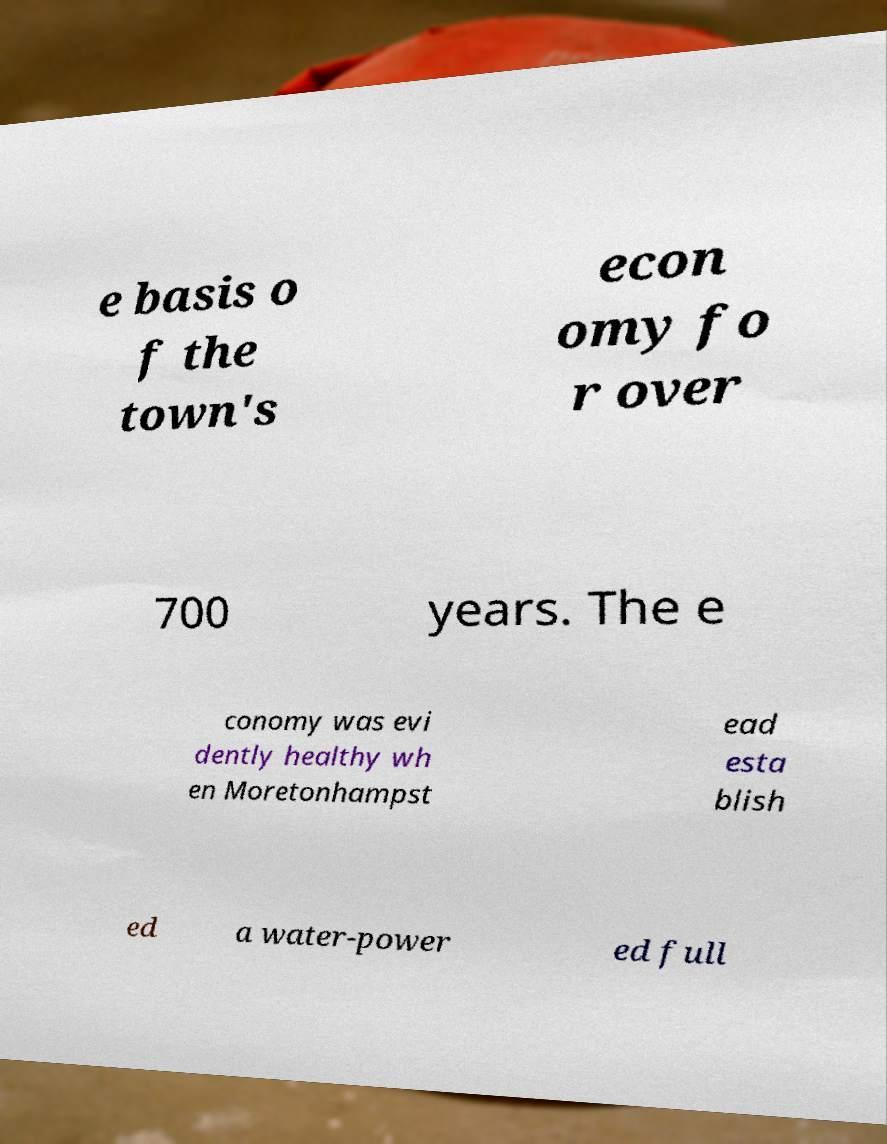What messages or text are displayed in this image? I need them in a readable, typed format. e basis o f the town's econ omy fo r over 700 years. The e conomy was evi dently healthy wh en Moretonhampst ead esta blish ed a water-power ed full 